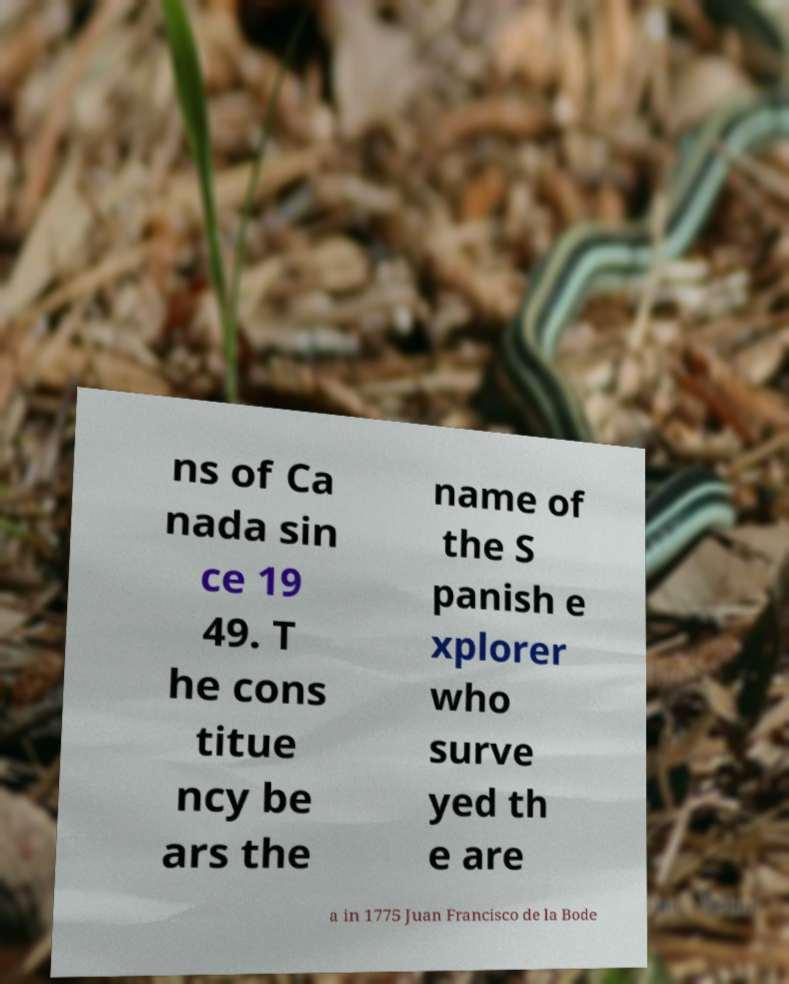For documentation purposes, I need the text within this image transcribed. Could you provide that? ns of Ca nada sin ce 19 49. T he cons titue ncy be ars the name of the S panish e xplorer who surve yed th e are a in 1775 Juan Francisco de la Bode 